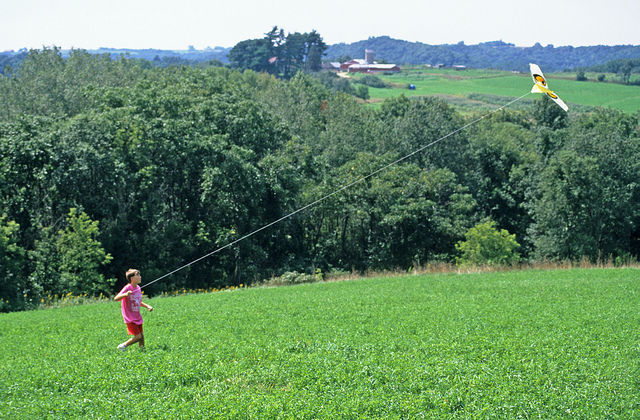What activity is the child engaged in? The child is flying a kite on a grassy hill, enjoying the outdoor recreational activity which can be both fun and relaxing. 